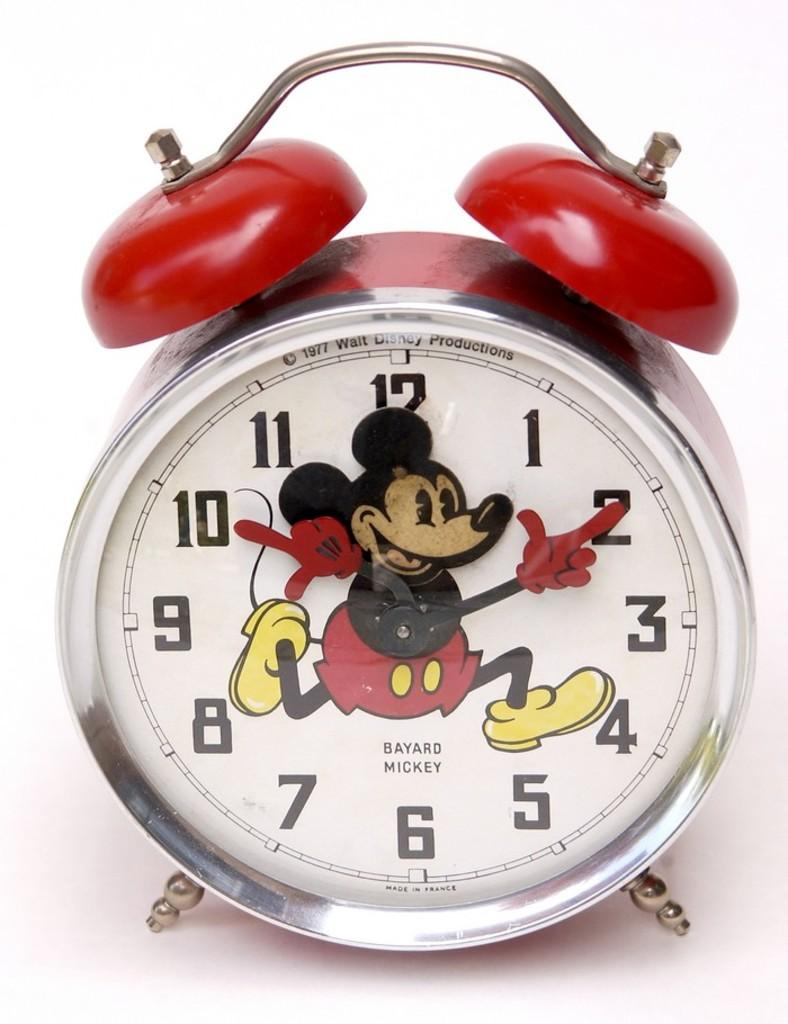<image>
Write a terse but informative summary of the picture. a mickey mouse style clock that says bayard mickey 